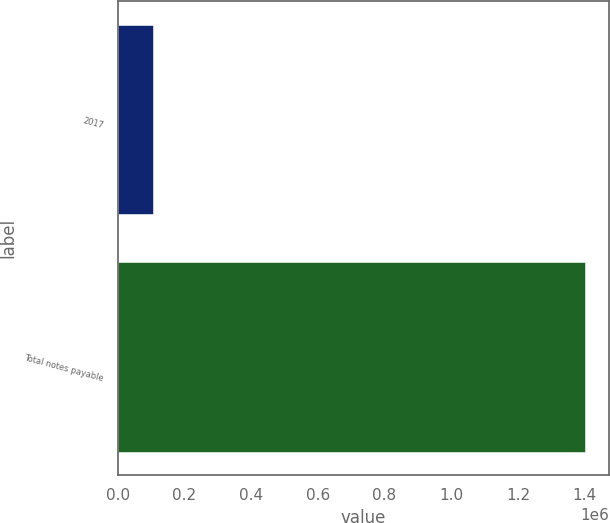Convert chart. <chart><loc_0><loc_0><loc_500><loc_500><bar_chart><fcel>2017<fcel>Total notes payable<nl><fcel>104662<fcel>1.40198e+06<nl></chart> 